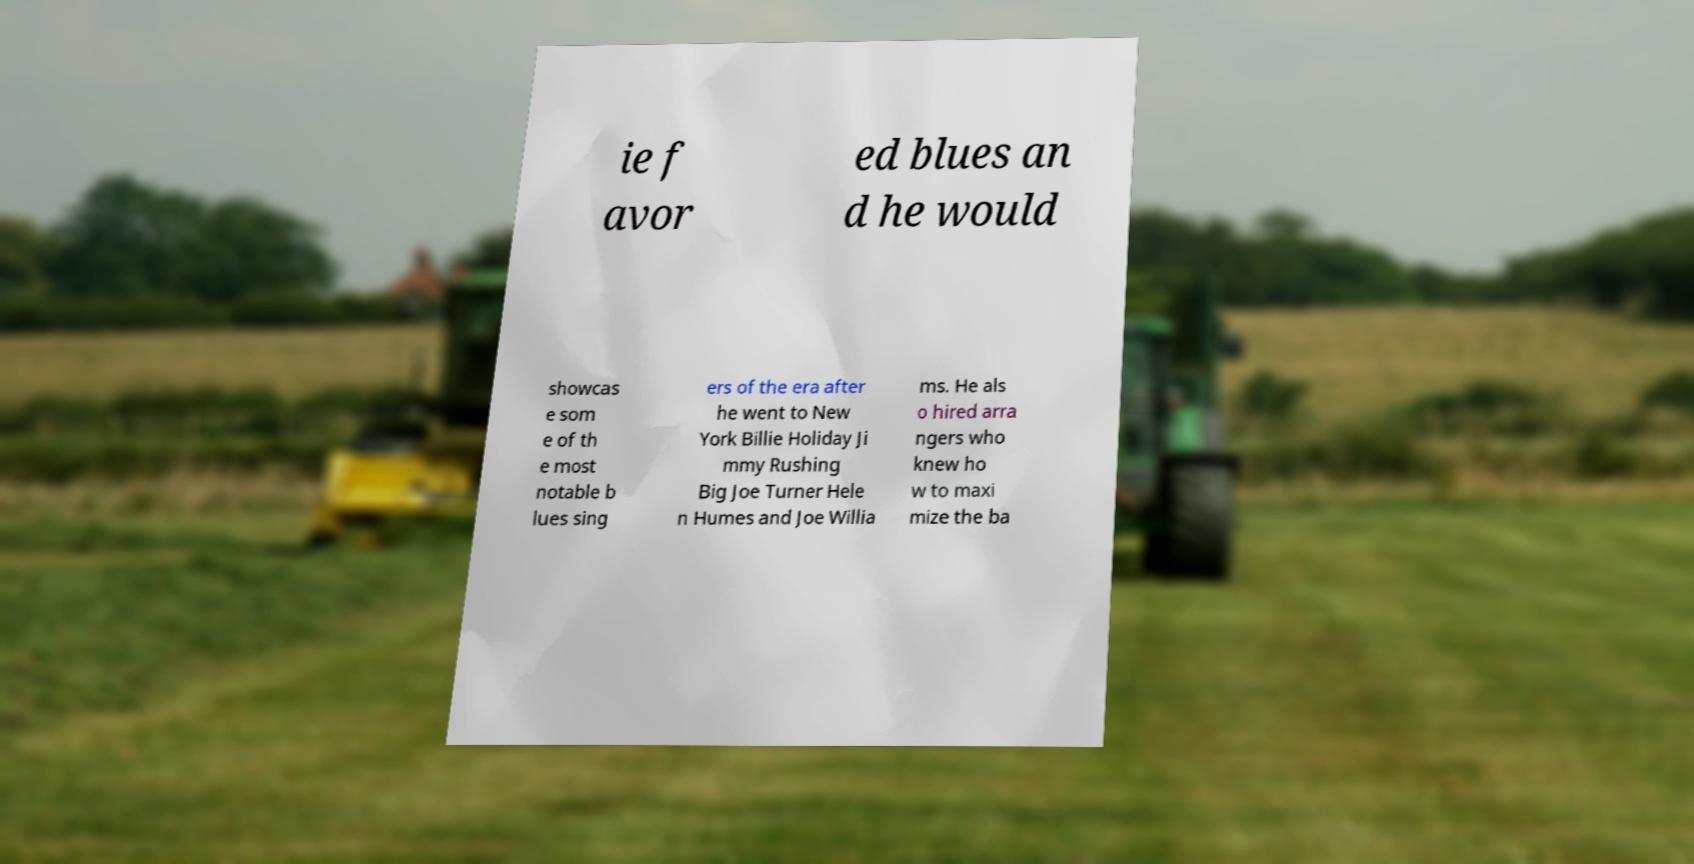There's text embedded in this image that I need extracted. Can you transcribe it verbatim? ie f avor ed blues an d he would showcas e som e of th e most notable b lues sing ers of the era after he went to New York Billie Holiday Ji mmy Rushing Big Joe Turner Hele n Humes and Joe Willia ms. He als o hired arra ngers who knew ho w to maxi mize the ba 